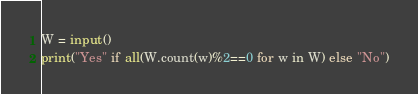<code> <loc_0><loc_0><loc_500><loc_500><_Python_>W = input()
print("Yes" if all(W.count(w)%2==0 for w in W) else "No")</code> 